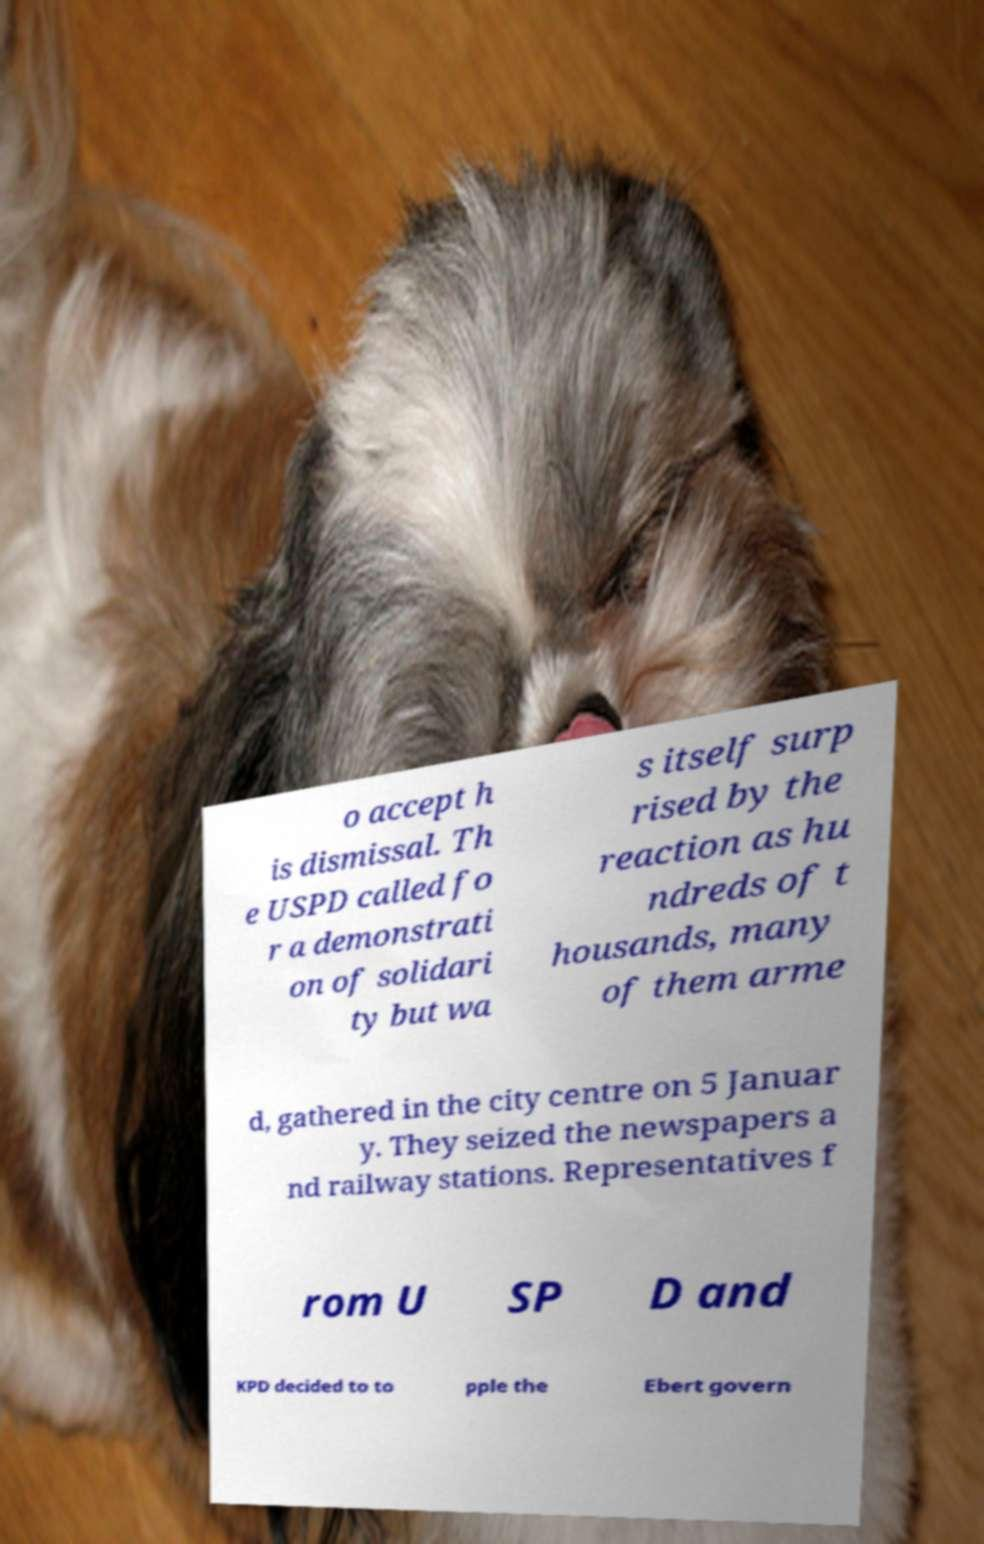Could you assist in decoding the text presented in this image and type it out clearly? o accept h is dismissal. Th e USPD called fo r a demonstrati on of solidari ty but wa s itself surp rised by the reaction as hu ndreds of t housands, many of them arme d, gathered in the city centre on 5 Januar y. They seized the newspapers a nd railway stations. Representatives f rom U SP D and KPD decided to to pple the Ebert govern 